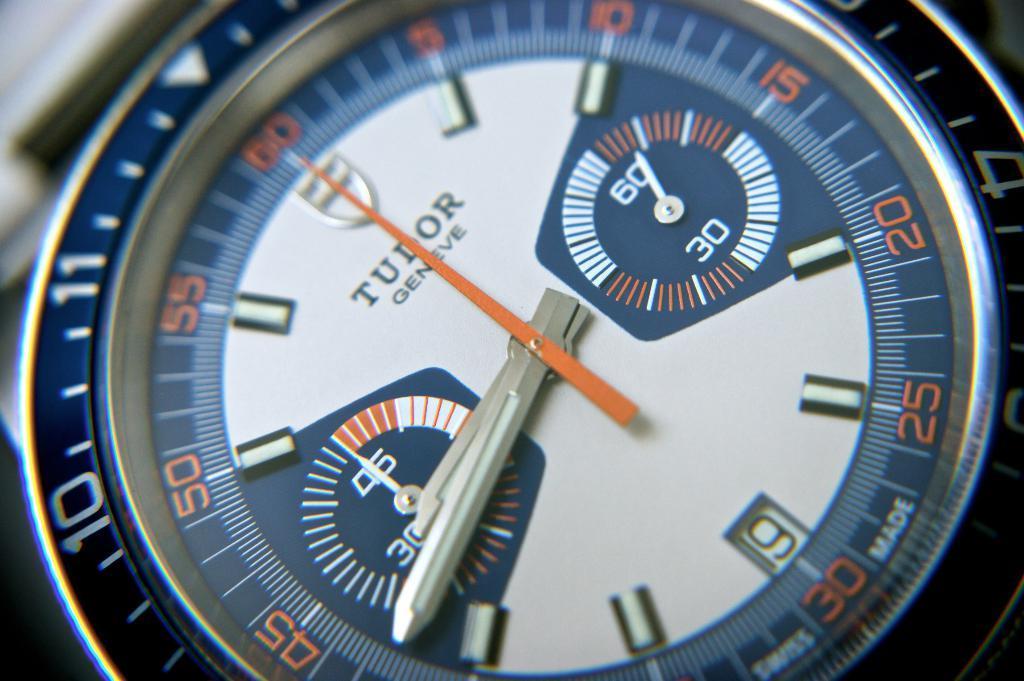How would you summarize this image in a sentence or two? In this image there is a diaper of a wrist watch. 